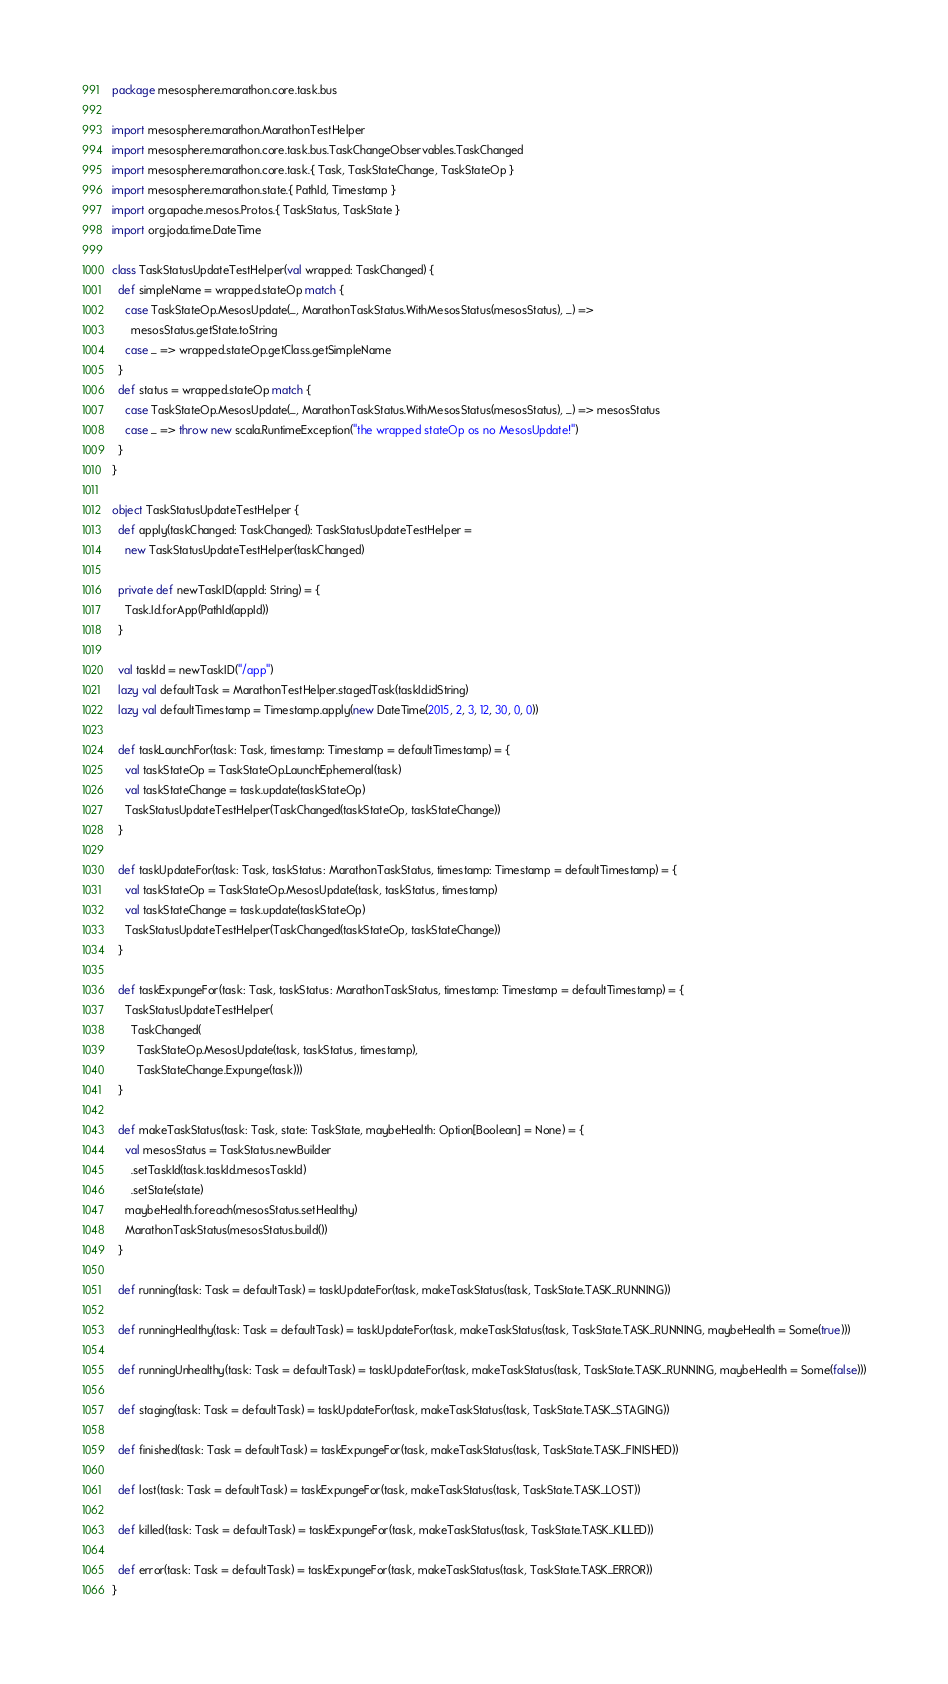<code> <loc_0><loc_0><loc_500><loc_500><_Scala_>package mesosphere.marathon.core.task.bus

import mesosphere.marathon.MarathonTestHelper
import mesosphere.marathon.core.task.bus.TaskChangeObservables.TaskChanged
import mesosphere.marathon.core.task.{ Task, TaskStateChange, TaskStateOp }
import mesosphere.marathon.state.{ PathId, Timestamp }
import org.apache.mesos.Protos.{ TaskStatus, TaskState }
import org.joda.time.DateTime

class TaskStatusUpdateTestHelper(val wrapped: TaskChanged) {
  def simpleName = wrapped.stateOp match {
    case TaskStateOp.MesosUpdate(_, MarathonTaskStatus.WithMesosStatus(mesosStatus), _) =>
      mesosStatus.getState.toString
    case _ => wrapped.stateOp.getClass.getSimpleName
  }
  def status = wrapped.stateOp match {
    case TaskStateOp.MesosUpdate(_, MarathonTaskStatus.WithMesosStatus(mesosStatus), _) => mesosStatus
    case _ => throw new scala.RuntimeException("the wrapped stateOp os no MesosUpdate!")
  }
}

object TaskStatusUpdateTestHelper {
  def apply(taskChanged: TaskChanged): TaskStatusUpdateTestHelper =
    new TaskStatusUpdateTestHelper(taskChanged)

  private def newTaskID(appId: String) = {
    Task.Id.forApp(PathId(appId))
  }

  val taskId = newTaskID("/app")
  lazy val defaultTask = MarathonTestHelper.stagedTask(taskId.idString)
  lazy val defaultTimestamp = Timestamp.apply(new DateTime(2015, 2, 3, 12, 30, 0, 0))

  def taskLaunchFor(task: Task, timestamp: Timestamp = defaultTimestamp) = {
    val taskStateOp = TaskStateOp.LaunchEphemeral(task)
    val taskStateChange = task.update(taskStateOp)
    TaskStatusUpdateTestHelper(TaskChanged(taskStateOp, taskStateChange))
  }

  def taskUpdateFor(task: Task, taskStatus: MarathonTaskStatus, timestamp: Timestamp = defaultTimestamp) = {
    val taskStateOp = TaskStateOp.MesosUpdate(task, taskStatus, timestamp)
    val taskStateChange = task.update(taskStateOp)
    TaskStatusUpdateTestHelper(TaskChanged(taskStateOp, taskStateChange))
  }

  def taskExpungeFor(task: Task, taskStatus: MarathonTaskStatus, timestamp: Timestamp = defaultTimestamp) = {
    TaskStatusUpdateTestHelper(
      TaskChanged(
        TaskStateOp.MesosUpdate(task, taskStatus, timestamp),
        TaskStateChange.Expunge(task)))
  }

  def makeTaskStatus(task: Task, state: TaskState, maybeHealth: Option[Boolean] = None) = {
    val mesosStatus = TaskStatus.newBuilder
      .setTaskId(task.taskId.mesosTaskId)
      .setState(state)
    maybeHealth.foreach(mesosStatus.setHealthy)
    MarathonTaskStatus(mesosStatus.build())
  }

  def running(task: Task = defaultTask) = taskUpdateFor(task, makeTaskStatus(task, TaskState.TASK_RUNNING))

  def runningHealthy(task: Task = defaultTask) = taskUpdateFor(task, makeTaskStatus(task, TaskState.TASK_RUNNING, maybeHealth = Some(true)))

  def runningUnhealthy(task: Task = defaultTask) = taskUpdateFor(task, makeTaskStatus(task, TaskState.TASK_RUNNING, maybeHealth = Some(false)))

  def staging(task: Task = defaultTask) = taskUpdateFor(task, makeTaskStatus(task, TaskState.TASK_STAGING))

  def finished(task: Task = defaultTask) = taskExpungeFor(task, makeTaskStatus(task, TaskState.TASK_FINISHED))

  def lost(task: Task = defaultTask) = taskExpungeFor(task, makeTaskStatus(task, TaskState.TASK_LOST))

  def killed(task: Task = defaultTask) = taskExpungeFor(task, makeTaskStatus(task, TaskState.TASK_KILLED))

  def error(task: Task = defaultTask) = taskExpungeFor(task, makeTaskStatus(task, TaskState.TASK_ERROR))
}
</code> 